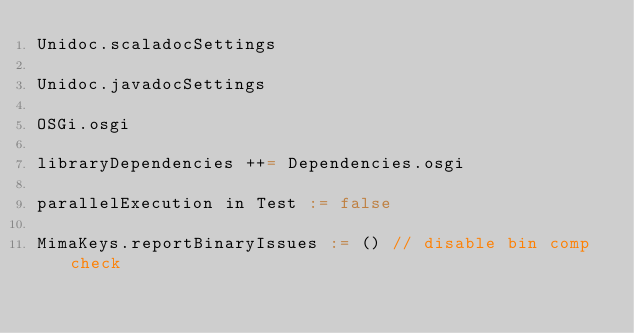Convert code to text. <code><loc_0><loc_0><loc_500><loc_500><_Scala_>Unidoc.scaladocSettings

Unidoc.javadocSettings

OSGi.osgi

libraryDependencies ++= Dependencies.osgi

parallelExecution in Test := false

MimaKeys.reportBinaryIssues := () // disable bin comp check
</code> 